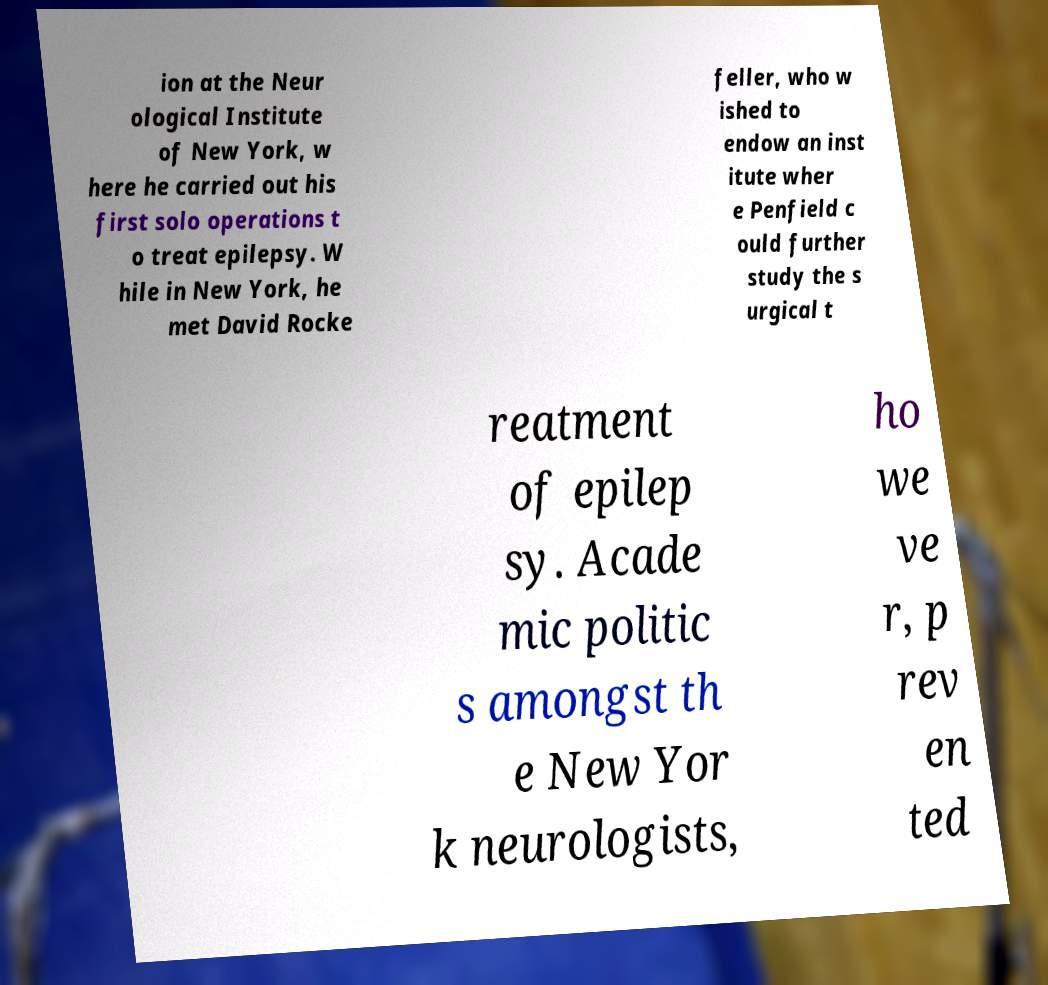There's text embedded in this image that I need extracted. Can you transcribe it verbatim? ion at the Neur ological Institute of New York, w here he carried out his first solo operations t o treat epilepsy. W hile in New York, he met David Rocke feller, who w ished to endow an inst itute wher e Penfield c ould further study the s urgical t reatment of epilep sy. Acade mic politic s amongst th e New Yor k neurologists, ho we ve r, p rev en ted 